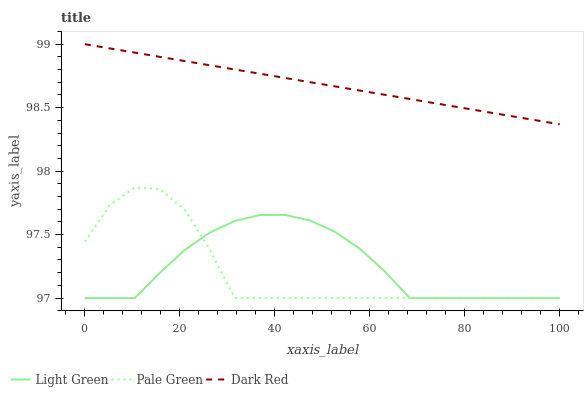Does Pale Green have the minimum area under the curve?
Answer yes or no. Yes. Does Dark Red have the maximum area under the curve?
Answer yes or no. Yes. Does Light Green have the minimum area under the curve?
Answer yes or no. No. Does Light Green have the maximum area under the curve?
Answer yes or no. No. Is Dark Red the smoothest?
Answer yes or no. Yes. Is Pale Green the roughest?
Answer yes or no. Yes. Is Light Green the smoothest?
Answer yes or no. No. Is Light Green the roughest?
Answer yes or no. No. Does Pale Green have the lowest value?
Answer yes or no. Yes. Does Dark Red have the highest value?
Answer yes or no. Yes. Does Pale Green have the highest value?
Answer yes or no. No. Is Light Green less than Dark Red?
Answer yes or no. Yes. Is Dark Red greater than Light Green?
Answer yes or no. Yes. Does Light Green intersect Pale Green?
Answer yes or no. Yes. Is Light Green less than Pale Green?
Answer yes or no. No. Is Light Green greater than Pale Green?
Answer yes or no. No. Does Light Green intersect Dark Red?
Answer yes or no. No. 